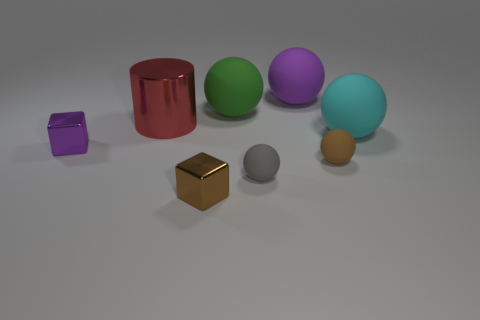Subtract all green balls. How many balls are left? 4 Add 1 purple matte balls. How many objects exist? 9 Subtract all brown cubes. How many cubes are left? 1 Subtract 4 balls. How many balls are left? 1 Subtract all cylinders. How many objects are left? 7 Subtract all big cyan spheres. Subtract all brown balls. How many objects are left? 6 Add 2 big purple rubber objects. How many big purple rubber objects are left? 3 Add 6 brown rubber spheres. How many brown rubber spheres exist? 7 Subtract 0 red balls. How many objects are left? 8 Subtract all purple cylinders. Subtract all purple blocks. How many cylinders are left? 1 